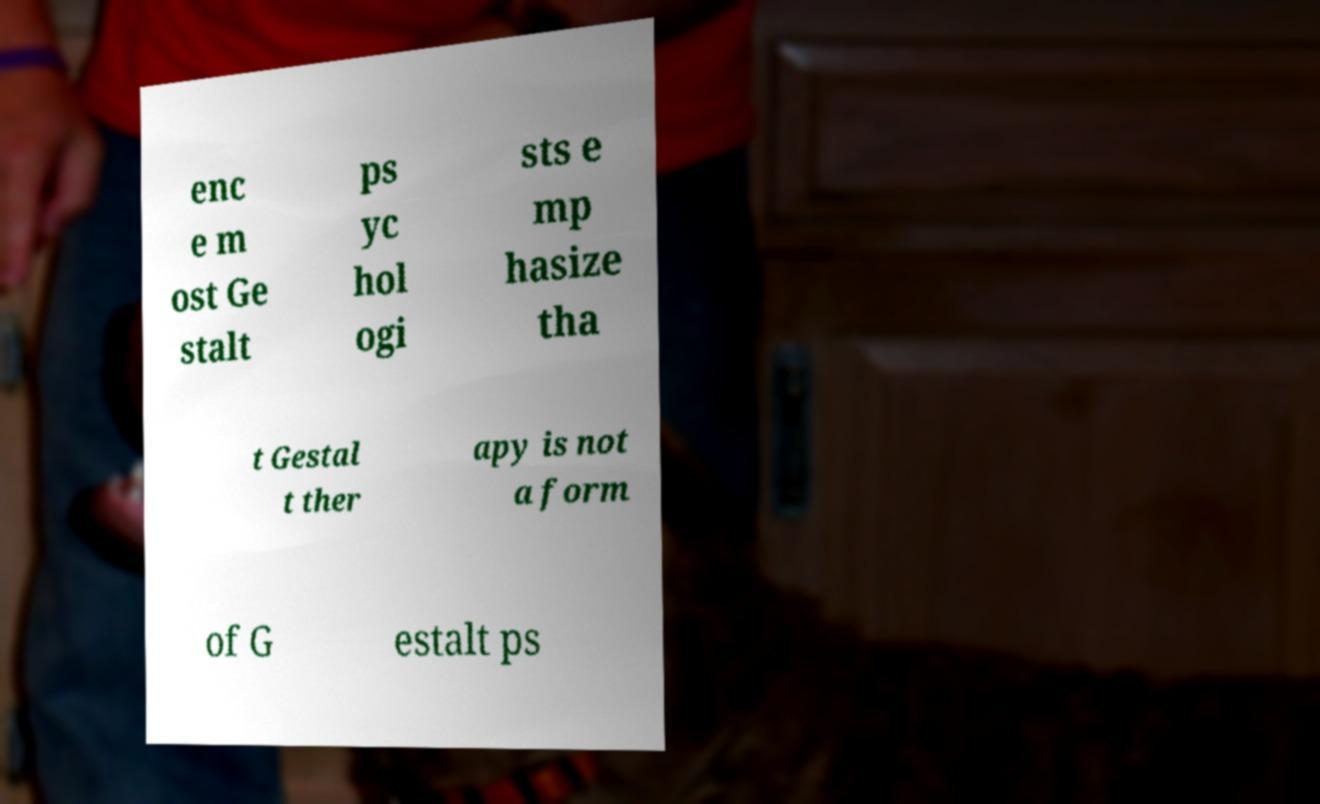I need the written content from this picture converted into text. Can you do that? enc e m ost Ge stalt ps yc hol ogi sts e mp hasize tha t Gestal t ther apy is not a form of G estalt ps 